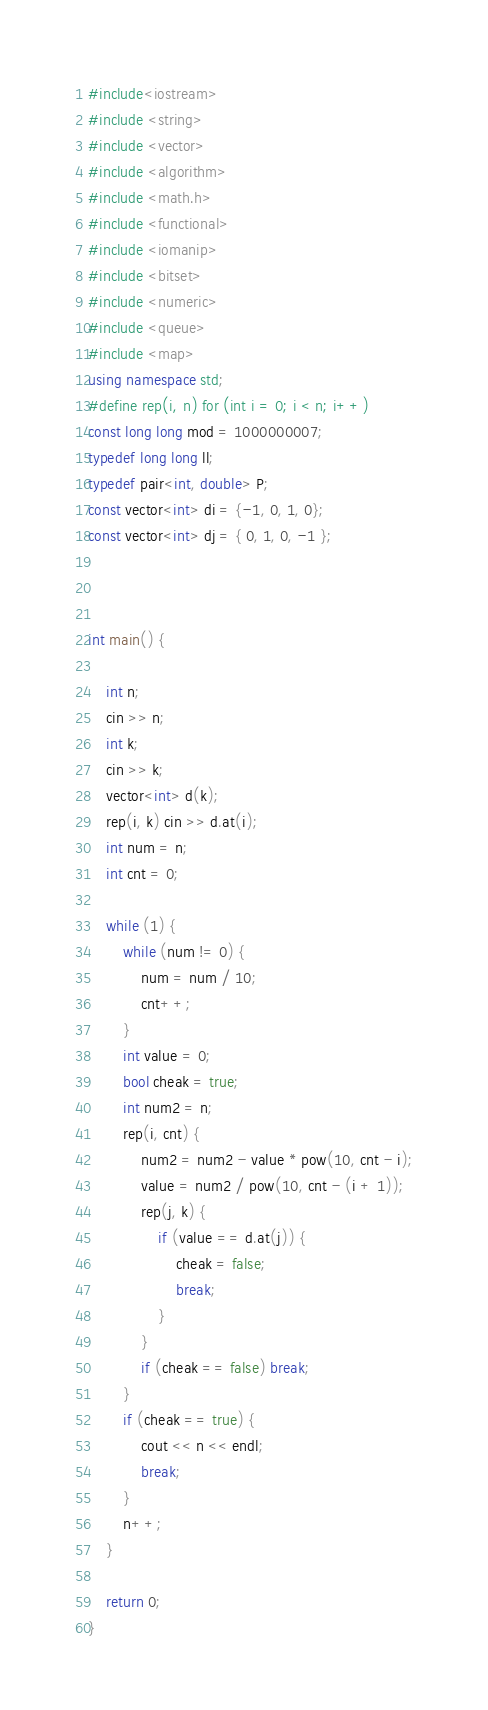Convert code to text. <code><loc_0><loc_0><loc_500><loc_500><_C++_>#include<iostream>
#include <string>
#include <vector>
#include <algorithm>
#include <math.h>
#include <functional>
#include <iomanip>
#include <bitset>
#include <numeric>
#include <queue>
#include <map>
using namespace std;
#define rep(i, n) for (int i = 0; i < n; i++)
const long long mod = 1000000007;
typedef long long ll;
typedef pair<int, double> P;
const vector<int> di = {-1, 0, 1, 0};
const vector<int> dj = { 0, 1, 0, -1 };



int main() {

	int n;
	cin >> n;
	int k;
	cin >> k;
	vector<int> d(k);
	rep(i, k) cin >> d.at(i);
	int num = n;
	int cnt = 0;

	while (1) {
		while (num != 0) {
			num = num / 10;
			cnt++;
		}
		int value = 0;
		bool cheak = true;
		int num2 = n;
		rep(i, cnt) {
			num2 = num2 - value * pow(10, cnt - i);
			value = num2 / pow(10, cnt - (i + 1));
			rep(j, k) {
				if (value == d.at(j)) {
					cheak = false;
					break;
				}
			}
			if (cheak == false) break;
		}
		if (cheak == true) {
			cout << n << endl;
			break;
		}
		n++;
	}
	
	return 0;
}</code> 